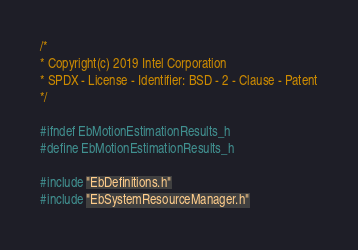Convert code to text. <code><loc_0><loc_0><loc_500><loc_500><_C_>/*
* Copyright(c) 2019 Intel Corporation
* SPDX - License - Identifier: BSD - 2 - Clause - Patent
*/

#ifndef EbMotionEstimationResults_h
#define EbMotionEstimationResults_h

#include "EbDefinitions.h"
#include "EbSystemResourceManager.h"</code> 